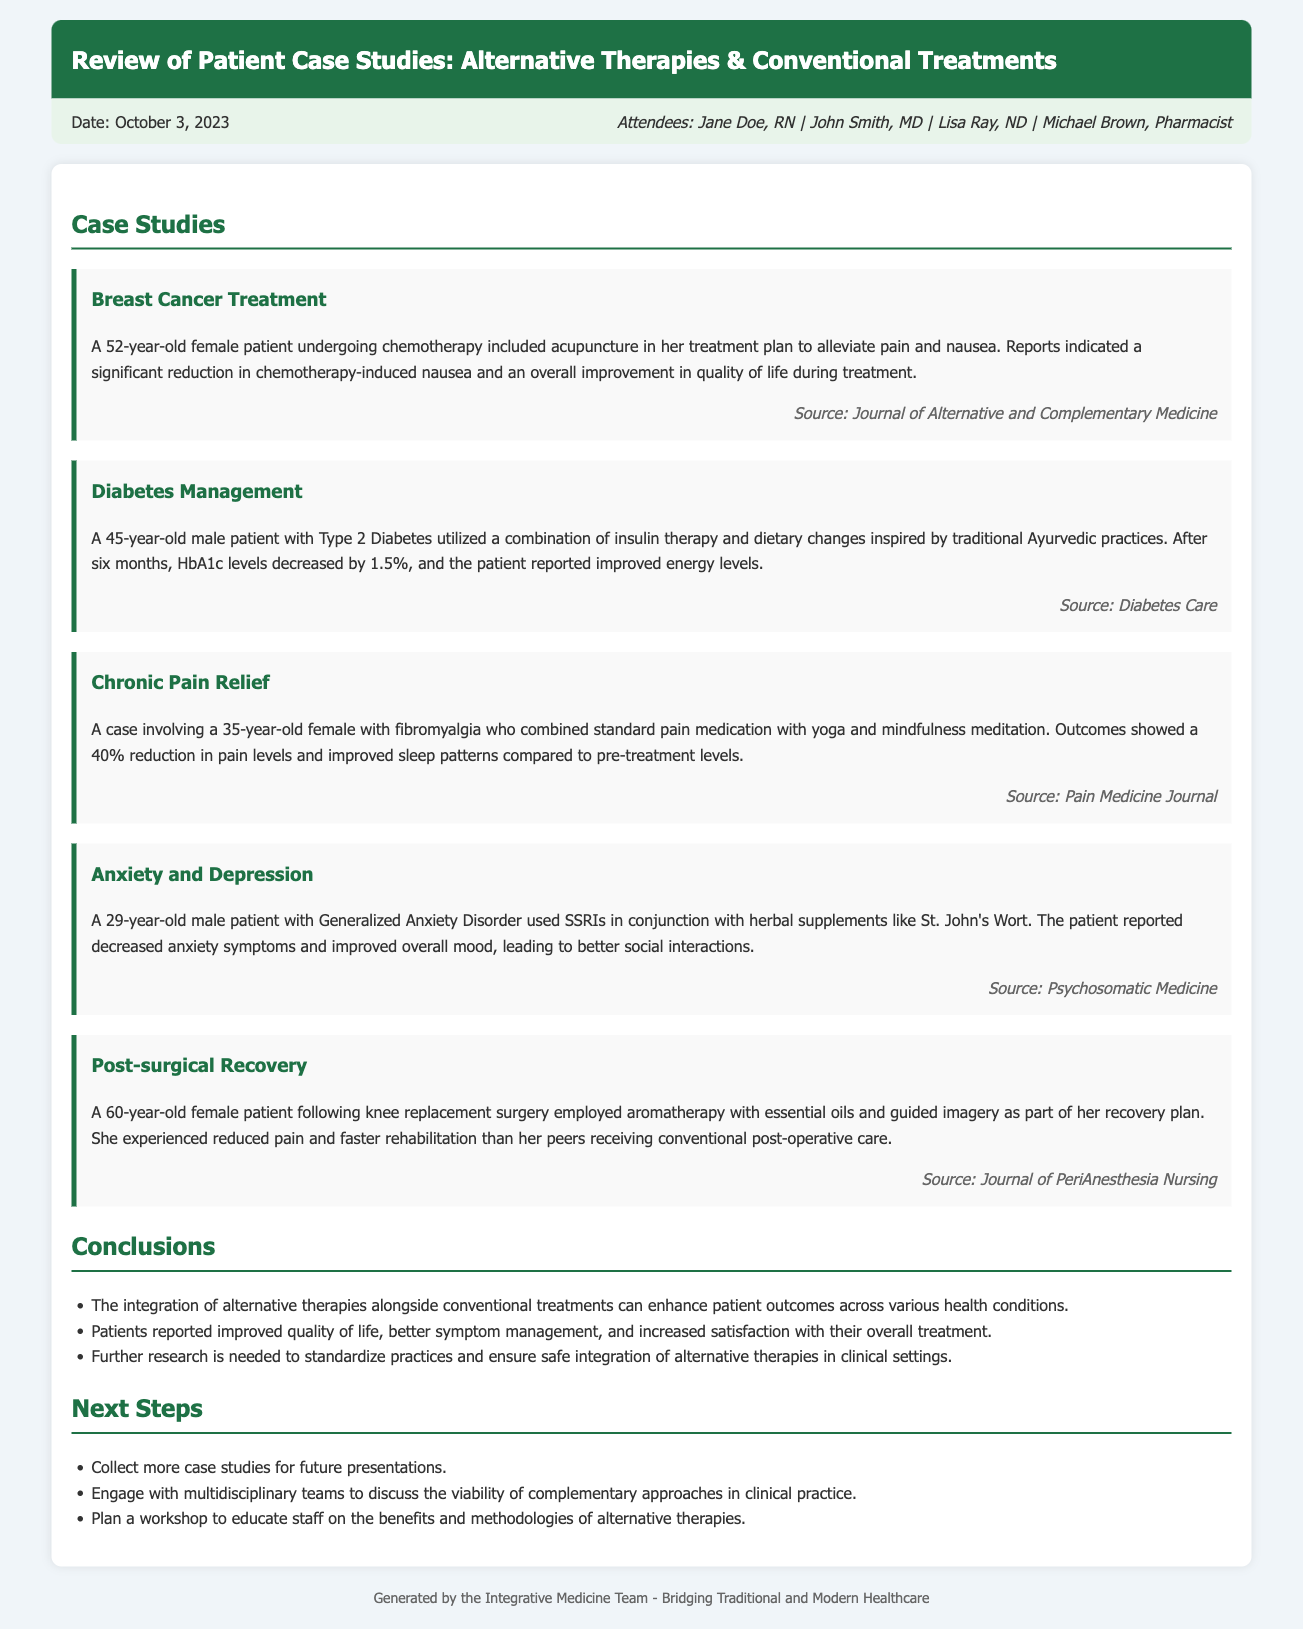What is the date of the meeting? The date of the meeting is mentioned at the beginning of the document.
Answer: October 3, 2023 Who is one of the attendees of the meeting? The attendees list includes names of individuals who participated in the meeting.
Answer: Jane Doe What therapy was integrated into the breast cancer treatment case study? The case study highlights specific alternative therapies used alongside conventional treatments.
Answer: Acupuncture What was the percentage reduction in pain levels for the fibromyalgia patient? The document states the outcomes of combining traditional and alternative therapies for pain relief.
Answer: 40% What is one key conclusion from the meeting? This summarizes the discussion points mentioned in the conclusions section.
Answer: Enhanced patient outcomes What was the age of the patient in the diabetes management case study? The document specifies the age of the male patient discussed in the case study.
Answer: 45 years old What will be planned to educate staff on alternative therapies? The "Next Steps" section outlines future actions decided during the meeting.
Answer: A workshop Which herbal supplement was used alongside SSRIs in the anxiety case study? The alternatives used in conjunction with conventional treatments are specified in the case study.
Answer: St. John's Wort 